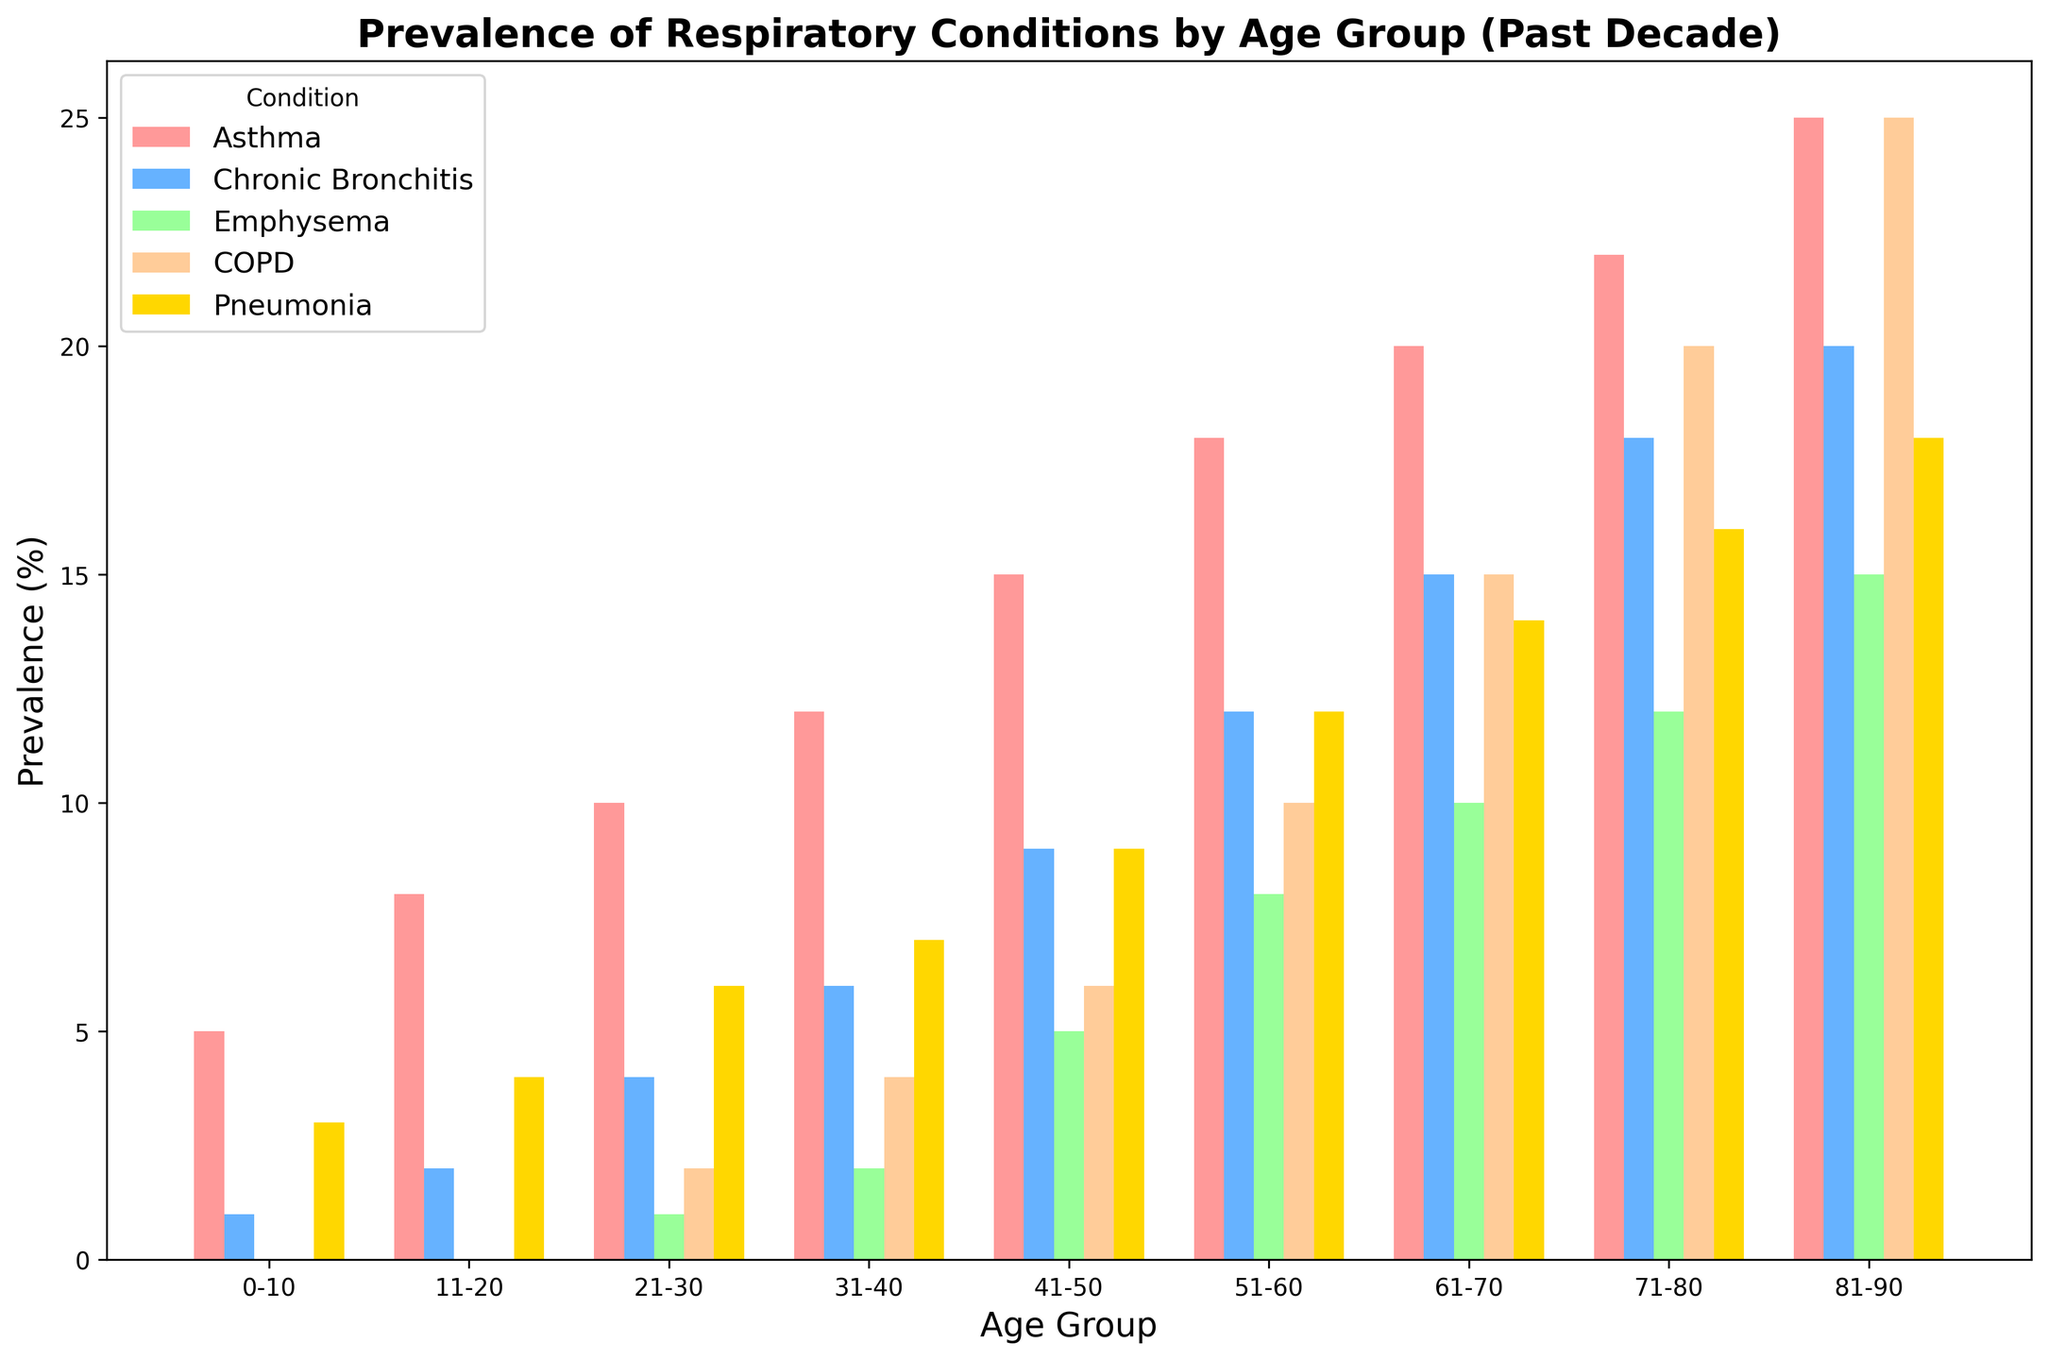What is the prevalence of Asthma in the 51-60 age group? Referring to the bar for Asthma in the 51-60 age group, we can see that the height of the bar indicates a prevalence of 18%.
Answer: 18% Which respiratory condition has the highest prevalence in individuals aged 61-70? By comparing the heights of the bars for each respiratory condition in the 61-70 age group, we see that Asthma has the highest prevalence at 20%.
Answer: Asthma What is the total prevalence of Chronic Bronchitis and Emphysema in the 31-40 age group? The prevalence of Chronic Bronchitis is 6% and Emphysema is 2% in the 31-40 age group. Adding them up gives 6 + 2 = 8%.
Answer: 8% In which age group does COPD show a significant increase compared to the previous age group? Comparing the bars for COPD across age groups, we see a noticeable increase from the 41-50 group (6%) to the 51-60 group (10%).
Answer: 51-60 How does the prevalence of Pneumonia change from the 0-10 age group to the 71-80 age group? The prevalence of Pneumonia in the 0-10 group is 3%, while in the 71-80 group it's 16%. This shows an increase of 16 - 3 = 13%.
Answer: Increases by 13% What is the average prevalence of Emphysema across all age groups? To find the average, sum the prevalence values for all age groups: 0+0+1+2+5+8+10+12+15 = 53. The number of age groups is 9. So, the average is 53 / 9 ≈ 5.89%.
Answer: 5.89% Which age group has the greatest difference in prevalence between Asthma and COPD? Subtract the prevalence of COPD from Asthma for each age group and find the maximum difference. For the 81-90 age group, Asthma is 25% and COPD is 25%, difference is 0%. The greatest difference is in the 0-10 group with Asthma at 5% and COPD at 0%, difference is 5%.
Answer: 0-10 What is the overall trend in the prevalence of Chronic Bronchitis with increasing age? By visually inspecting the bars for Chronic Bronchitis across age groups, we see that the prevalence consistently increases from the youngest (1%) to the oldest group (20%).
Answer: Consistently increases If you were to focus on the age group 41-50, which condition's prevalence would you address first based on the data? The highest bar in the 41-50 age group is for Asthma with a prevalence of 15%, so Asthma would be addressed first.
Answer: Asthma Which condition appears least prevalent across all age groups in the given data? Observing the bars for all conditions across all age groups, Emphysema consistently has the smallest bars indicating the lowest prevalence.
Answer: Emphysema 